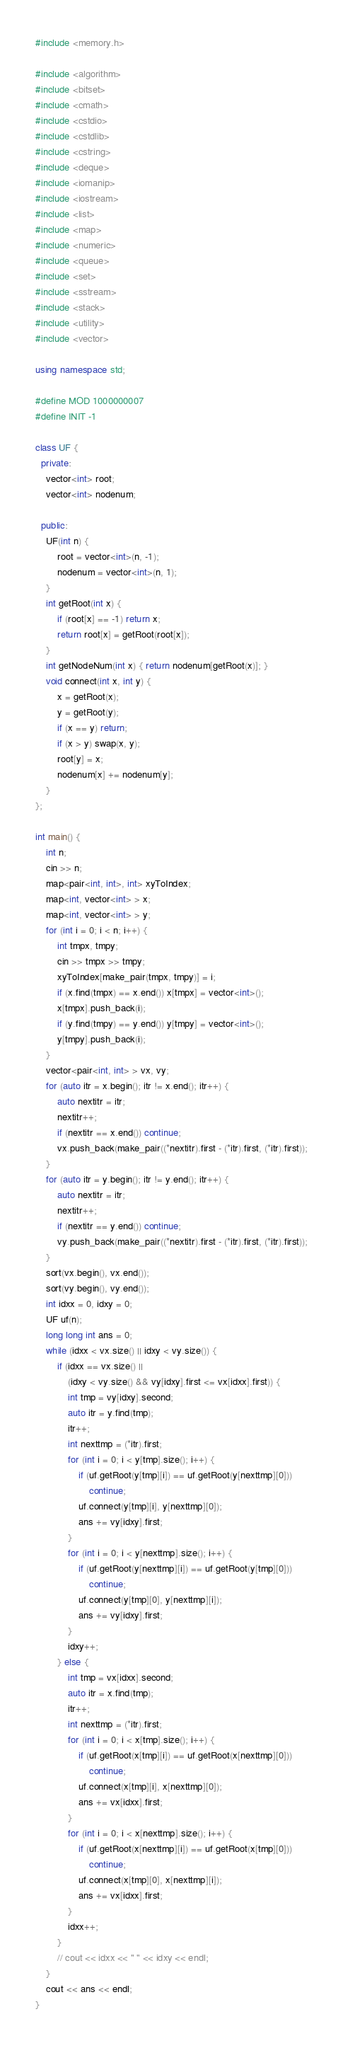Convert code to text. <code><loc_0><loc_0><loc_500><loc_500><_C++_>#include <memory.h>

#include <algorithm>
#include <bitset>
#include <cmath>
#include <cstdio>
#include <cstdlib>
#include <cstring>
#include <deque>
#include <iomanip>
#include <iostream>
#include <list>
#include <map>
#include <numeric>
#include <queue>
#include <set>
#include <sstream>
#include <stack>
#include <utility>
#include <vector>

using namespace std;

#define MOD 1000000007
#define INIT -1

class UF {
  private:
	vector<int> root;
	vector<int> nodenum;

  public:
	UF(int n) {
		root = vector<int>(n, -1);
		nodenum = vector<int>(n, 1);
	}
	int getRoot(int x) {
		if (root[x] == -1) return x;
		return root[x] = getRoot(root[x]);
	}
	int getNodeNum(int x) { return nodenum[getRoot(x)]; }
	void connect(int x, int y) {
		x = getRoot(x);
		y = getRoot(y);
		if (x == y) return;
		if (x > y) swap(x, y);
		root[y] = x;
		nodenum[x] += nodenum[y];
	}
};

int main() {
	int n;
	cin >> n;
	map<pair<int, int>, int> xyToIndex;
	map<int, vector<int> > x;
	map<int, vector<int> > y;
	for (int i = 0; i < n; i++) {
		int tmpx, tmpy;
		cin >> tmpx >> tmpy;
		xyToIndex[make_pair(tmpx, tmpy)] = i;
		if (x.find(tmpx) == x.end()) x[tmpx] = vector<int>();
		x[tmpx].push_back(i);
		if (y.find(tmpy) == y.end()) y[tmpy] = vector<int>();
		y[tmpy].push_back(i);
	}
	vector<pair<int, int> > vx, vy;
	for (auto itr = x.begin(); itr != x.end(); itr++) {
		auto nextitr = itr;
		nextitr++;
		if (nextitr == x.end()) continue;
		vx.push_back(make_pair((*nextitr).first - (*itr).first, (*itr).first));
	}
	for (auto itr = y.begin(); itr != y.end(); itr++) {
		auto nextitr = itr;
		nextitr++;
		if (nextitr == y.end()) continue;
		vy.push_back(make_pair((*nextitr).first - (*itr).first, (*itr).first));
	}
	sort(vx.begin(), vx.end());
	sort(vy.begin(), vy.end());
	int idxx = 0, idxy = 0;
	UF uf(n);
	long long int ans = 0;
	while (idxx < vx.size() || idxy < vy.size()) {
		if (idxx == vx.size() ||
		    (idxy < vy.size() && vy[idxy].first <= vx[idxx].first)) {
			int tmp = vy[idxy].second;
			auto itr = y.find(tmp);
			itr++;
			int nexttmp = (*itr).first;
			for (int i = 0; i < y[tmp].size(); i++) {
				if (uf.getRoot(y[tmp][i]) == uf.getRoot(y[nexttmp][0]))
					continue;
				uf.connect(y[tmp][i], y[nexttmp][0]);
				ans += vy[idxy].first;
			}
			for (int i = 0; i < y[nexttmp].size(); i++) {
				if (uf.getRoot(y[nexttmp][i]) == uf.getRoot(y[tmp][0]))
					continue;
				uf.connect(y[tmp][0], y[nexttmp][i]);
				ans += vy[idxy].first;
			}
			idxy++;
		} else {
			int tmp = vx[idxx].second;
			auto itr = x.find(tmp);
			itr++;
			int nexttmp = (*itr).first;
			for (int i = 0; i < x[tmp].size(); i++) {
				if (uf.getRoot(x[tmp][i]) == uf.getRoot(x[nexttmp][0]))
					continue;
				uf.connect(x[tmp][i], x[nexttmp][0]);
				ans += vx[idxx].first;
			}
			for (int i = 0; i < x[nexttmp].size(); i++) {
				if (uf.getRoot(x[nexttmp][i]) == uf.getRoot(x[tmp][0]))
					continue;
				uf.connect(x[tmp][0], x[nexttmp][i]);
				ans += vx[idxx].first;
			}
			idxx++;
		}
		// cout << idxx << " " << idxy << endl;
	}
	cout << ans << endl;
}</code> 